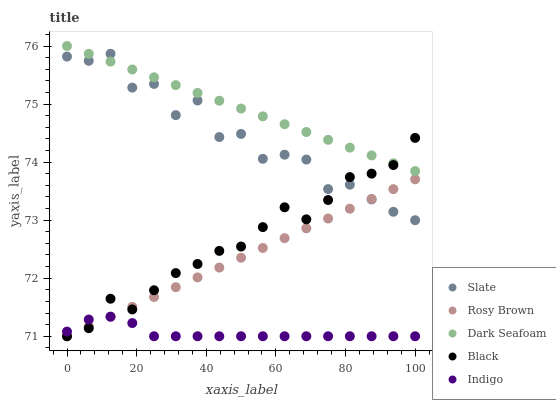Does Indigo have the minimum area under the curve?
Answer yes or no. Yes. Does Dark Seafoam have the maximum area under the curve?
Answer yes or no. Yes. Does Slate have the minimum area under the curve?
Answer yes or no. No. Does Slate have the maximum area under the curve?
Answer yes or no. No. Is Dark Seafoam the smoothest?
Answer yes or no. Yes. Is Slate the roughest?
Answer yes or no. Yes. Is Rosy Brown the smoothest?
Answer yes or no. No. Is Rosy Brown the roughest?
Answer yes or no. No. Does Indigo have the lowest value?
Answer yes or no. Yes. Does Slate have the lowest value?
Answer yes or no. No. Does Dark Seafoam have the highest value?
Answer yes or no. Yes. Does Slate have the highest value?
Answer yes or no. No. Is Indigo less than Slate?
Answer yes or no. Yes. Is Dark Seafoam greater than Rosy Brown?
Answer yes or no. Yes. Does Dark Seafoam intersect Slate?
Answer yes or no. Yes. Is Dark Seafoam less than Slate?
Answer yes or no. No. Is Dark Seafoam greater than Slate?
Answer yes or no. No. Does Indigo intersect Slate?
Answer yes or no. No. 